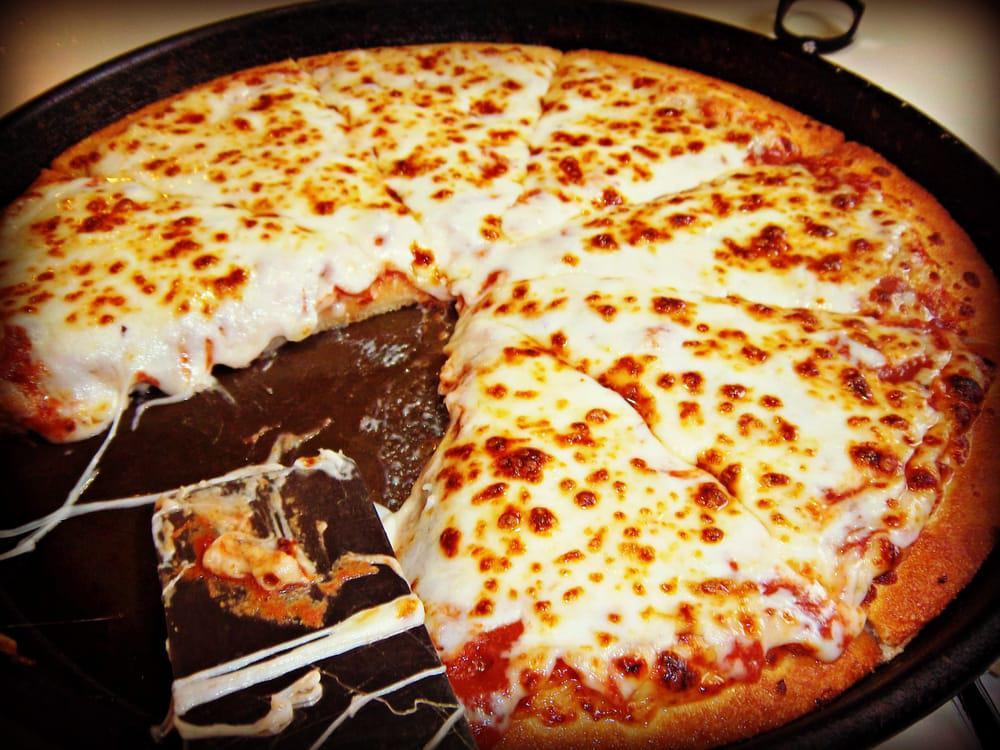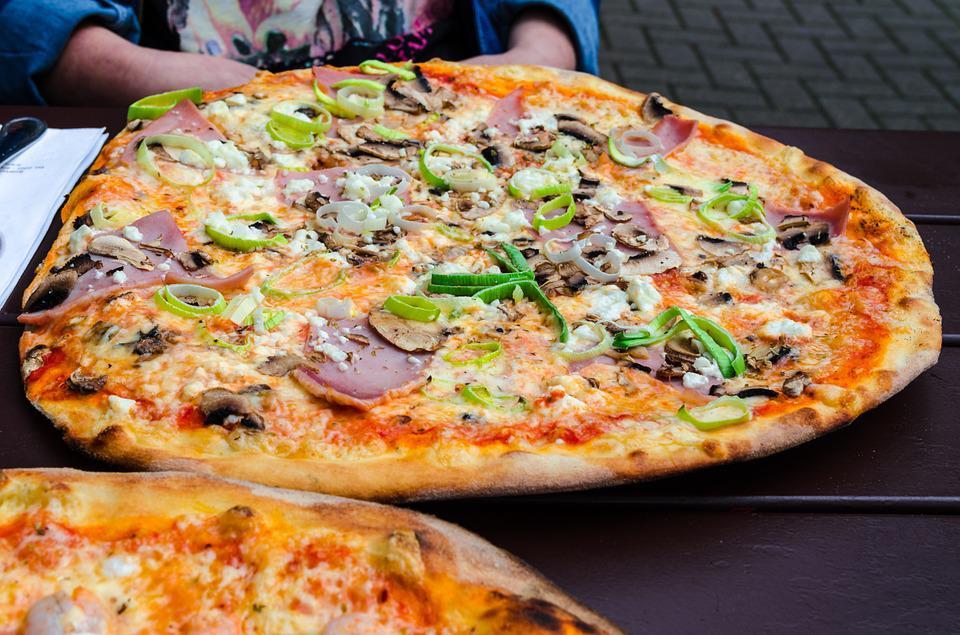The first image is the image on the left, the second image is the image on the right. Assess this claim about the two images: "One image has melted cheese stretched out between two pieces of food, and the other has a whole pizza.". Correct or not? Answer yes or no. Yes. The first image is the image on the left, the second image is the image on the right. For the images displayed, is the sentence "There is a total of two circle pizzas." factually correct? Answer yes or no. No. 